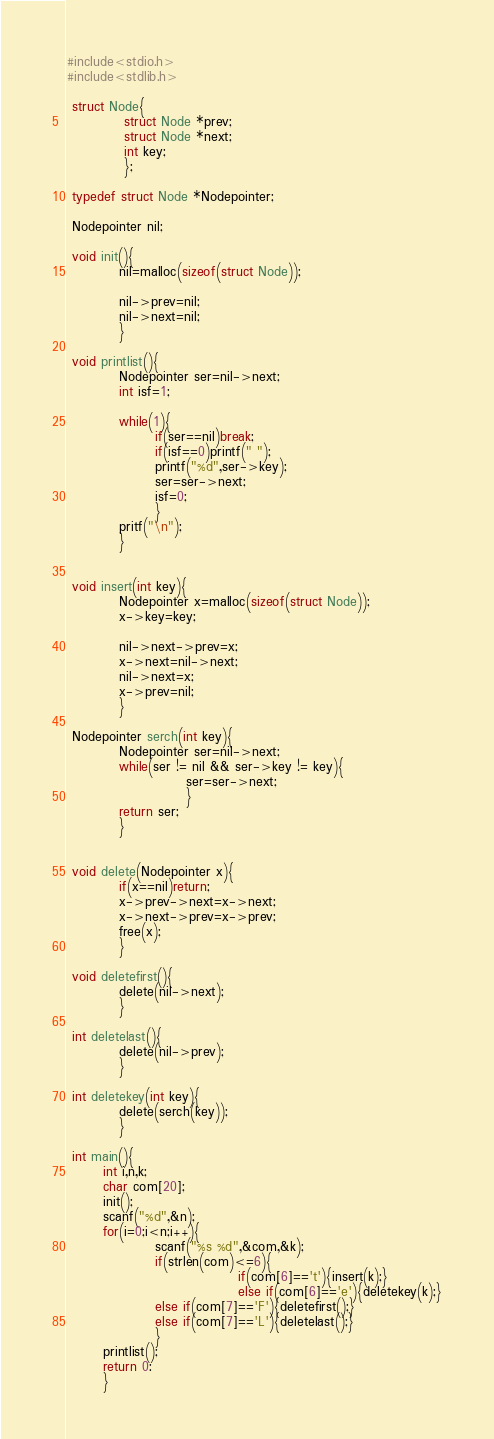<code> <loc_0><loc_0><loc_500><loc_500><_C_>#include<stdio.h>
#include<stdlib.h>

 struct Node{
           struct Node *prev;
           struct Node *next;
           int key;
           };

 typedef struct Node *Nodepointer;

 Nodepointer nil;

 void init(){
          nil=malloc(sizeof(struct Node));

          nil->prev=nil;
          nil->next=nil;
          }

 void printlist(){
          Nodepointer ser=nil->next;
          int isf=1;

          while(1){
                 if(ser==nil)break;
                 if(isf==0)printf(" ");
                 printf("%d",ser->key);
                 ser=ser->next;
                 isf=0;
                 }
          pritf("\n");
          }


 void insert(int key){
          Nodepointer x=malloc(sizeof(struct Node));
          x->key=key;

          nil->next->prev=x;
          x->next=nil->next;
          nil->next=x;
          x->prev=nil;
          }

 Nodepointer serch(int key){
          Nodepointer ser=nil->next;
          while(ser != nil && ser->key != key){
                       ser=ser->next;
                       }
          return ser;
          }
          

 void delete(Nodepointer x){
          if(x==nil)return;
          x->prev->next=x->next;
          x->next->prev=x->prev;
          free(x);
          }

 void deletefirst(){
          delete(nil->next);
          }

 int deletelast(){
          delete(nil->prev);
          }

 int deletekey(int key){
          delete(serch(key));
          }

 int main(){
       int i,n,k;
       char com[20];
       init();
       scanf("%d",&n);
       for(i=0;i<n;i++){
                 scanf("%s %d",&com,&k);
                 if(strlen(com)<=6){
                                 if(com[6]=='t'){insert(k);}
                                 else if(com[6]=='e'){deletekey(k);}
                 else if(com[7]=='F'){deletefirst();}
                 else if(com[7]=='L'){deletelast();}
                 }
       printlist();
       return 0:
       }





</code> 